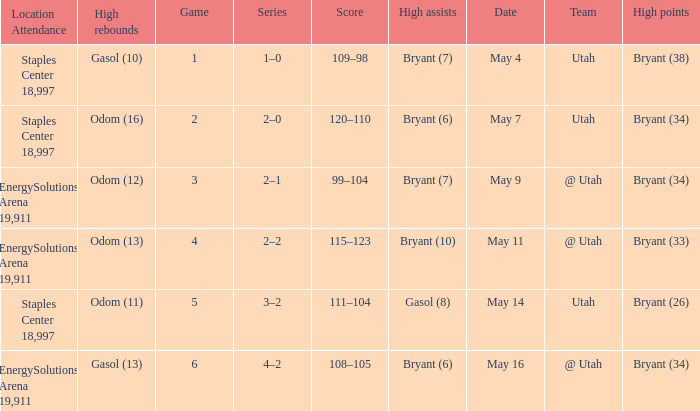What is the Series with a High rebounds with gasol (10)? 1–0. 